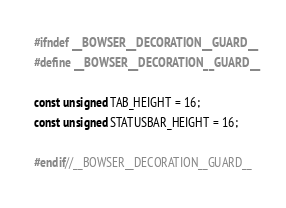<code> <loc_0><loc_0><loc_500><loc_500><_C++_>#ifndef __BOWSER__DECORATION__GUARD__
#define __BOWSER__DECORATION__GUARD__

const unsigned TAB_HEIGHT = 16;
const unsigned STATUSBAR_HEIGHT = 16;

#endif//__BOWSER__DECORATION__GUARD__
</code> 